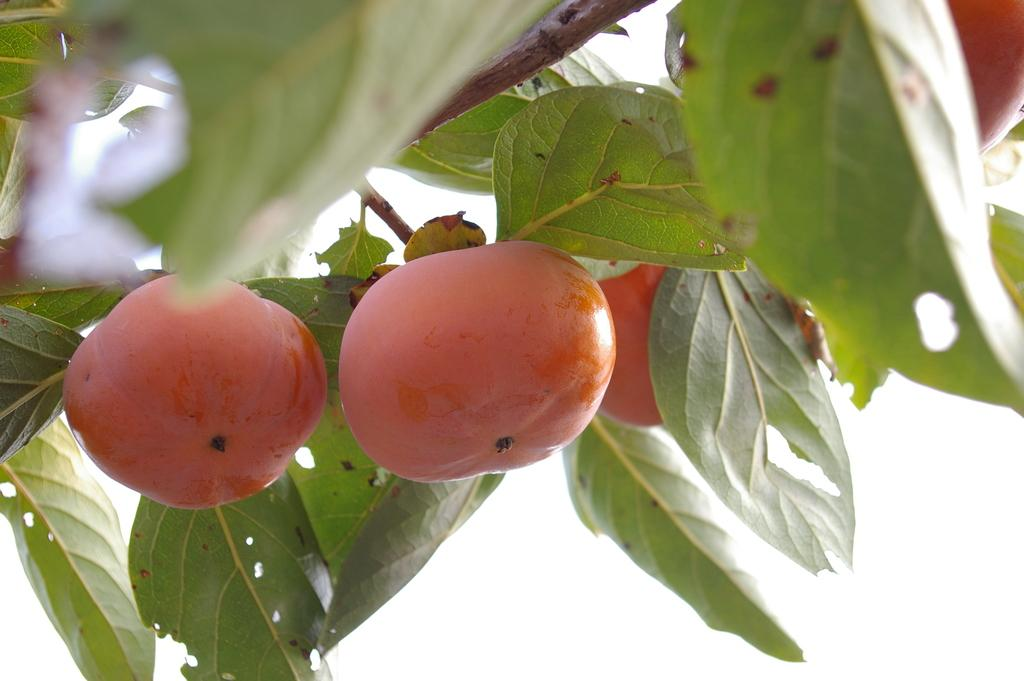What type of food can be seen in the image? There are fruits in the image. What color are the fruits in the image? The fruits are red in color. What else is present in the image besides the fruits? There are leaves in the image. What color are the leaves in the image? The leaves are green in color. What is the background color of the image? The background of the image is white. Can you see a ring on the goat's neck in the image? There is no goat present in the image, and therefore no ring on its neck can be observed. 